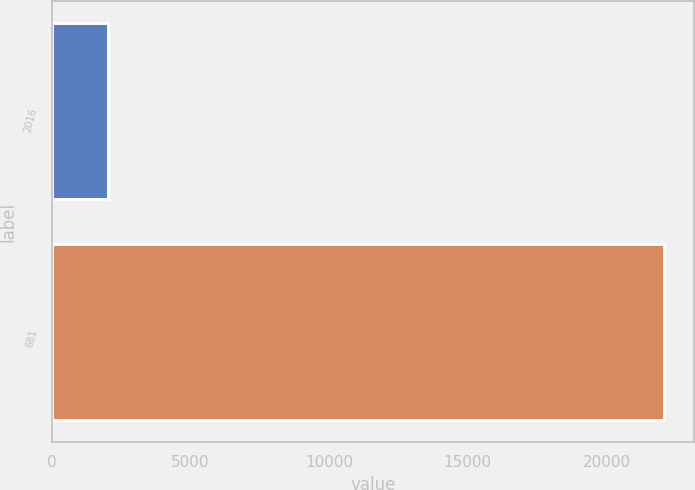<chart> <loc_0><loc_0><loc_500><loc_500><bar_chart><fcel>2016<fcel>681<nl><fcel>2015<fcel>22068<nl></chart> 